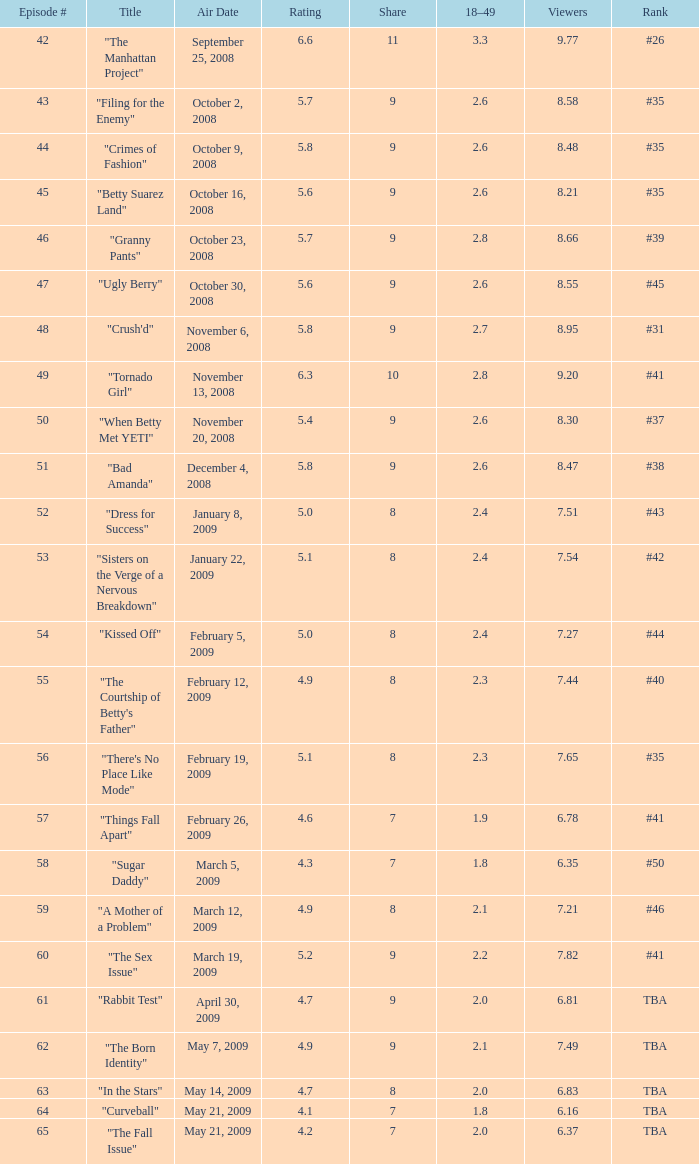What is the average Episode # with a 7 share and 18–49 is less than 2 and the Air Date of may 21, 2009? 64.0. 